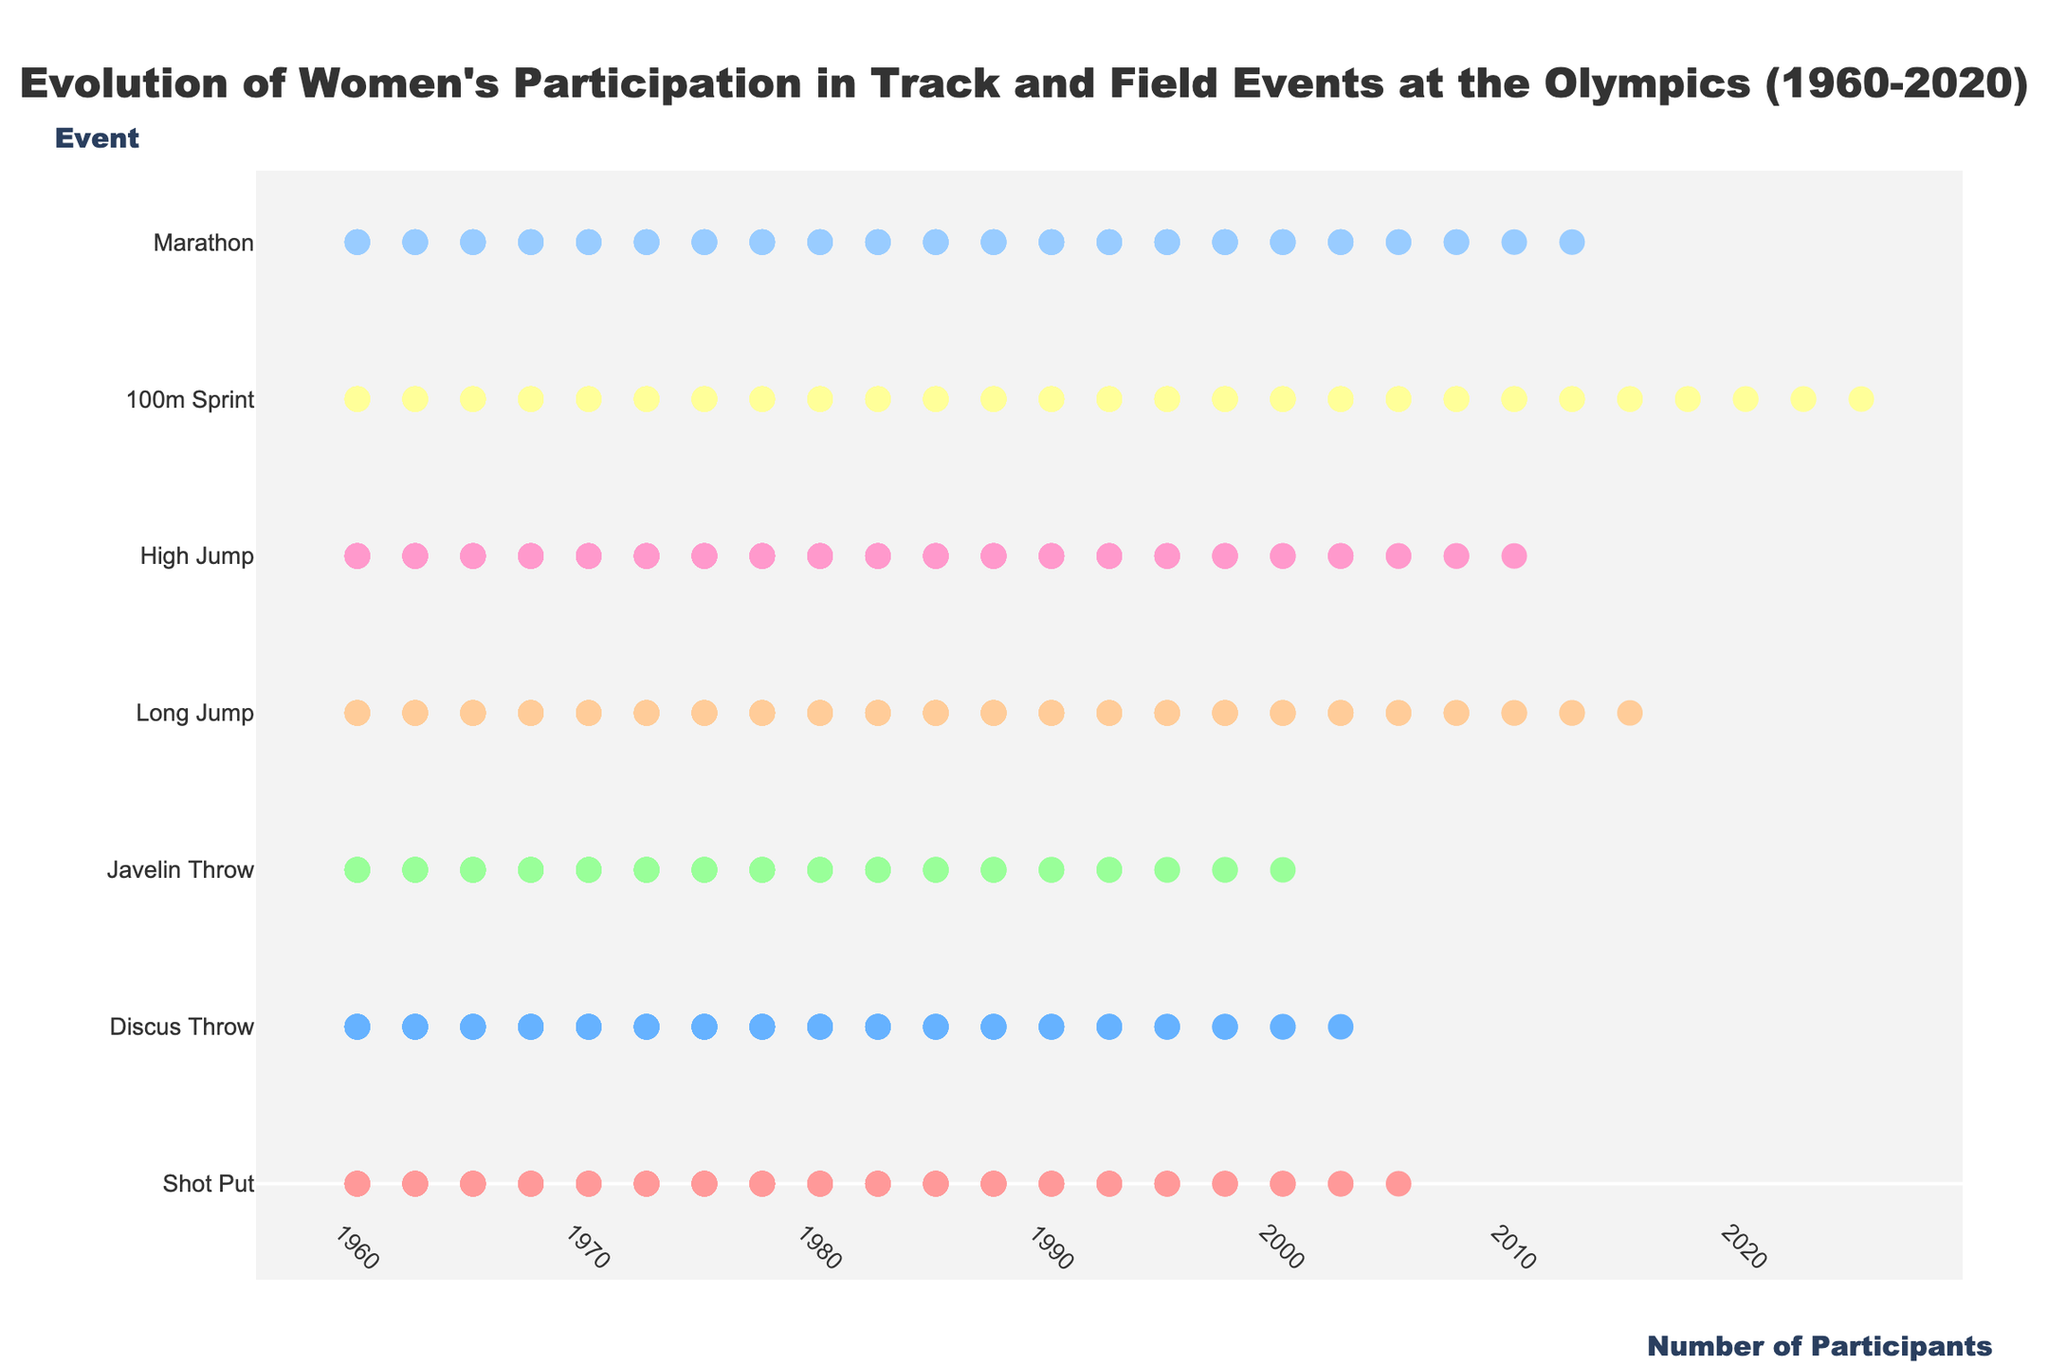How many women participated in the women's shot put event in 1960? According to the plot, there are 10 markers representing participants in the shot put event for 1960.
Answer: 10 Which year saw the highest participation in the women's 100m sprint? The plot shows the number of participants in the 100m sprint event reaching its peak in 2020 with 27 markers.
Answer: 2020 By how many participants did the marathon event grow from 1990 to 2020? The plot shows that the number of marathon participants increased from 16 in 1990 to 22 in 2020. The difference is 22 - 16 = 6.
Answer: 6 In which event and year did women's participation first appear for the marathon? The marathon event first shows participants in 1990, represented by 16 markers.
Answer: Marathon, 1990 How did the number of participants change for the discus throw event from 1960 to 2020? Starting with 8 participants in 1960, the plot shows a gradual increase to 18 participants in 2020. So, the change is 18 - 8 = 10.
Answer: 10 Comparing high jump and shot put in 2010, which event had more participants, and by how many? The plot shows 20 participants for the high jump and 18 for the shot put in 2010, with the high jump having 2 more participants than the shot put.
Answer: High Jump, 2 Which event had the smallest increase in the number of participants between 1960 and 2020? By comparing all events, shot put increased by 9 (19 - 10), which is the smallest increase.
Answer: Shot Put What's the average number of participants in the women's javelin throw event across all years provided? Summing the numbers for javelin throw: (6+8+10+12+14+16+17) = 83. The average is 83 / 7 = 11.86 (approximately).
Answer: 11.86 How many total events were represented in the plot? The list of events includes seven distinct entries: Shot Put, Discus Throw, Javelin Throw, Long Jump, High Jump, 100m Sprint, and Marathon.
Answer: 7 